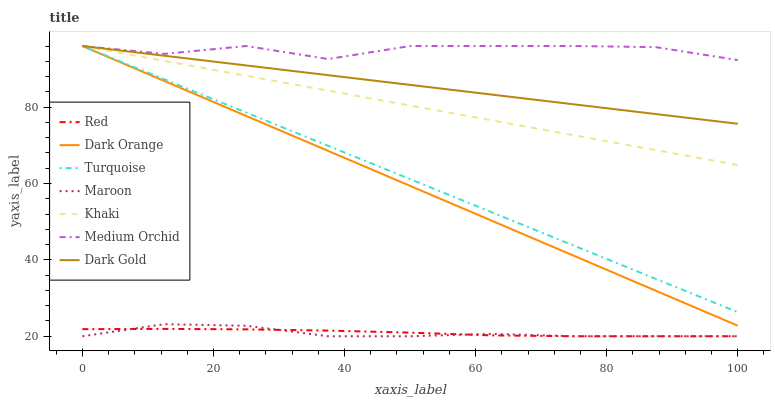Does Maroon have the minimum area under the curve?
Answer yes or no. Yes. Does Medium Orchid have the maximum area under the curve?
Answer yes or no. Yes. Does Turquoise have the minimum area under the curve?
Answer yes or no. No. Does Turquoise have the maximum area under the curve?
Answer yes or no. No. Is Dark Orange the smoothest?
Answer yes or no. Yes. Is Medium Orchid the roughest?
Answer yes or no. Yes. Is Turquoise the smoothest?
Answer yes or no. No. Is Turquoise the roughest?
Answer yes or no. No. Does Maroon have the lowest value?
Answer yes or no. Yes. Does Turquoise have the lowest value?
Answer yes or no. No. Does Medium Orchid have the highest value?
Answer yes or no. Yes. Does Maroon have the highest value?
Answer yes or no. No. Is Maroon less than Medium Orchid?
Answer yes or no. Yes. Is Khaki greater than Red?
Answer yes or no. Yes. Does Khaki intersect Dark Gold?
Answer yes or no. Yes. Is Khaki less than Dark Gold?
Answer yes or no. No. Is Khaki greater than Dark Gold?
Answer yes or no. No. Does Maroon intersect Medium Orchid?
Answer yes or no. No. 